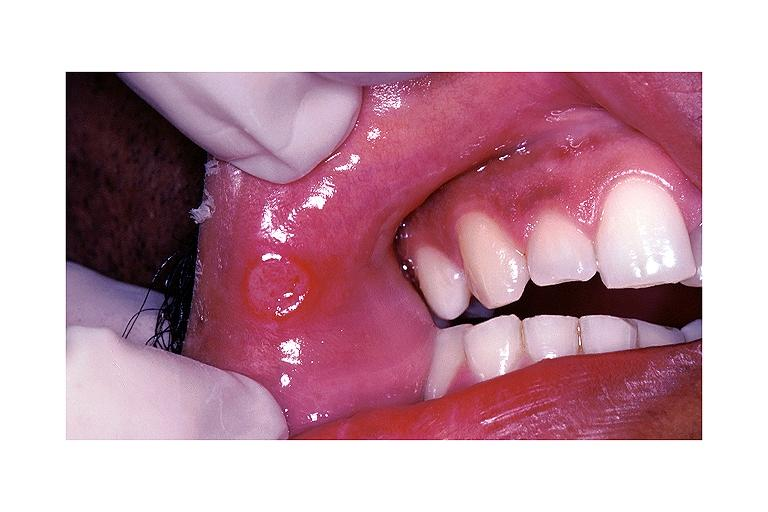does this image show aphthous ulcer?
Answer the question using a single word or phrase. Yes 